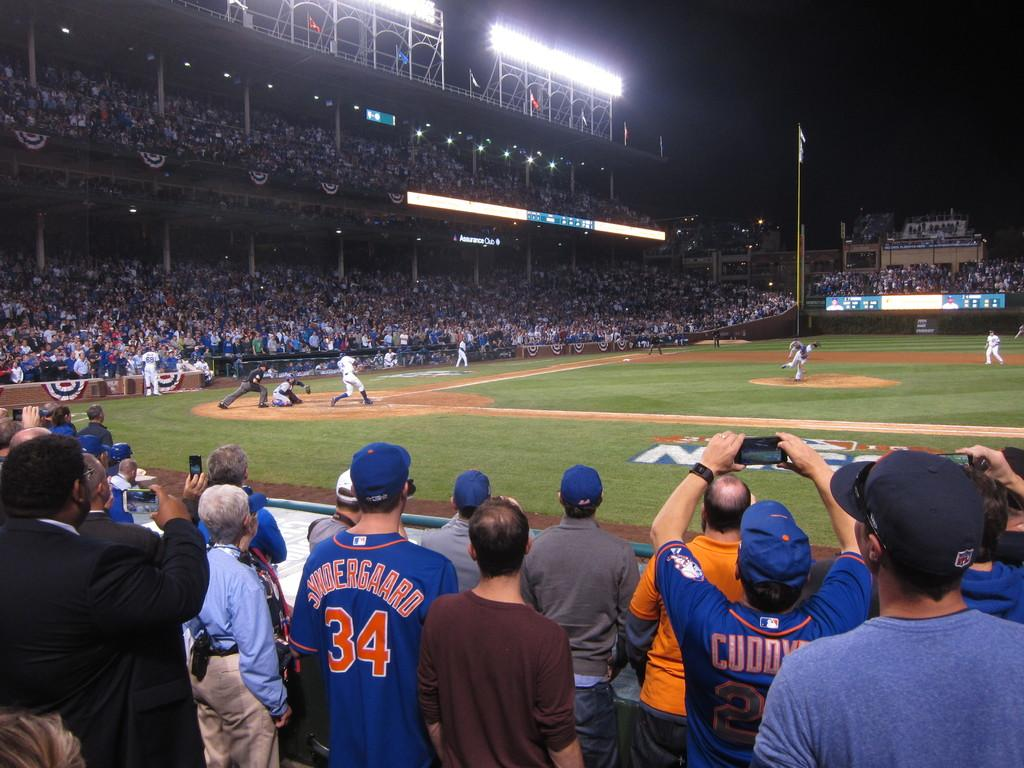<image>
Write a terse but informative summary of the picture. one of the fans of the blue team is wearing a number 34 jersey 